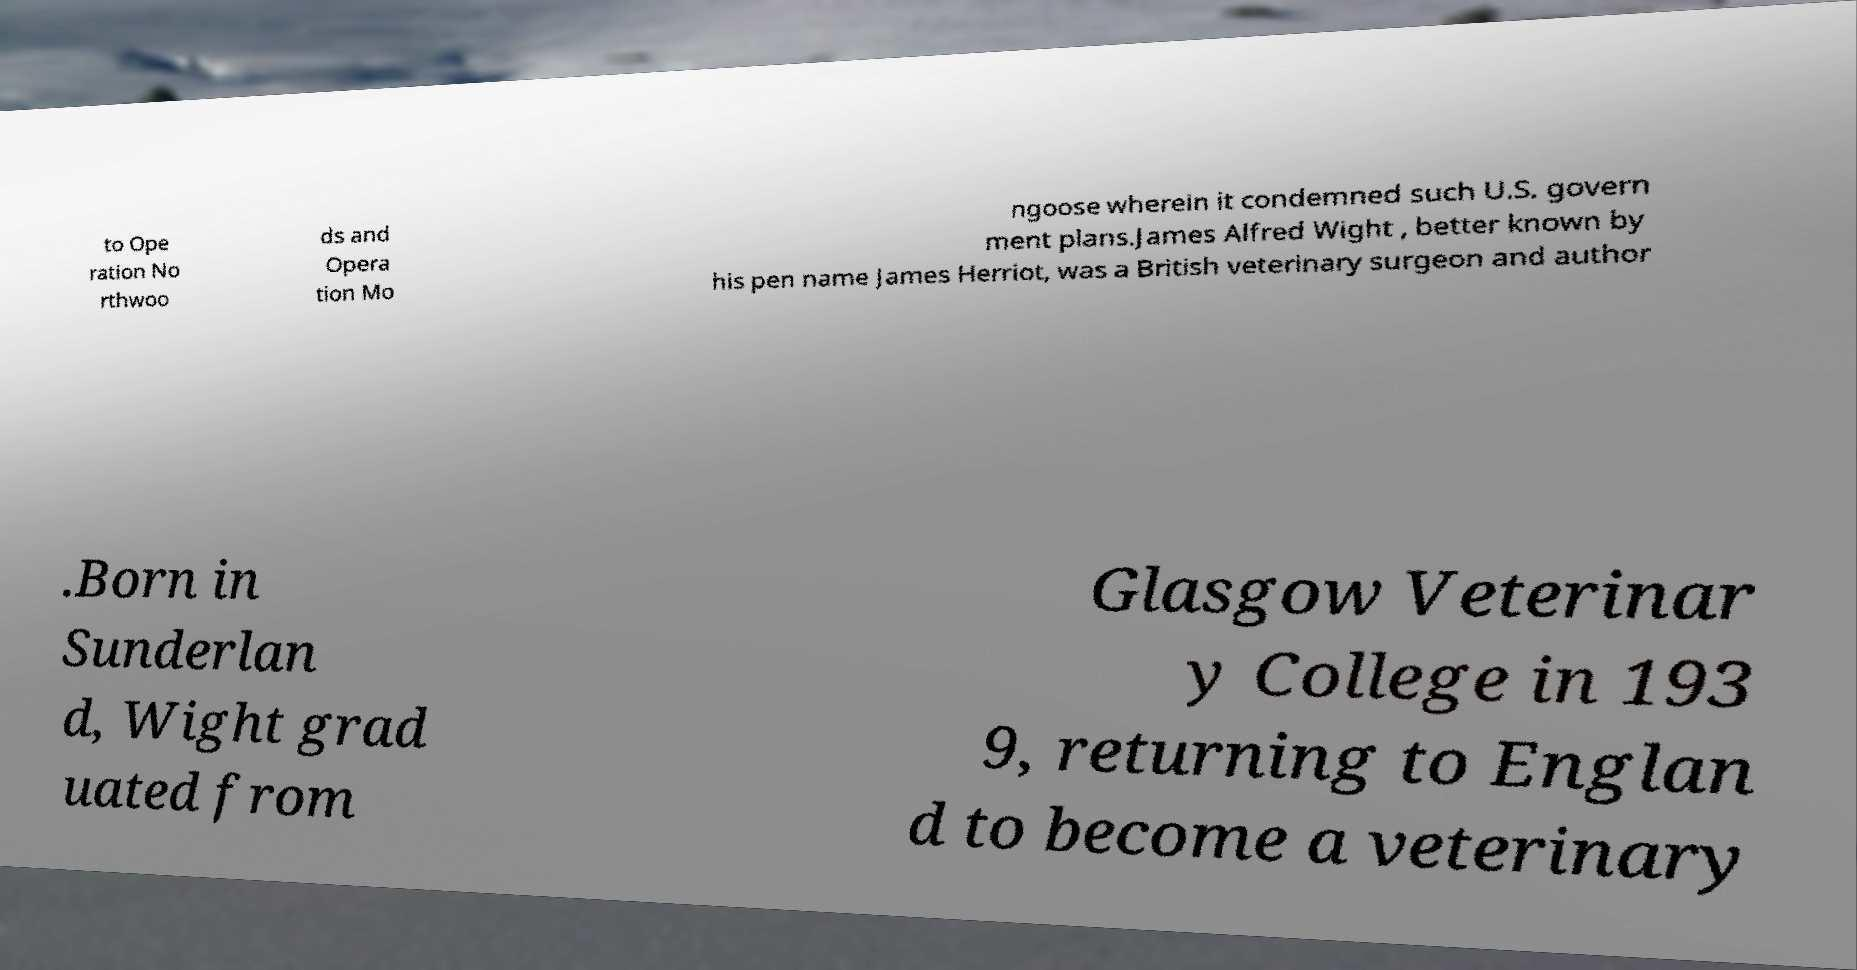Can you accurately transcribe the text from the provided image for me? to Ope ration No rthwoo ds and Opera tion Mo ngoose wherein it condemned such U.S. govern ment plans.James Alfred Wight , better known by his pen name James Herriot, was a British veterinary surgeon and author .Born in Sunderlan d, Wight grad uated from Glasgow Veterinar y College in 193 9, returning to Englan d to become a veterinary 